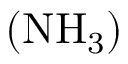<formula> <loc_0><loc_0><loc_500><loc_500>\left ( N H _ { 3 } \right )</formula> 